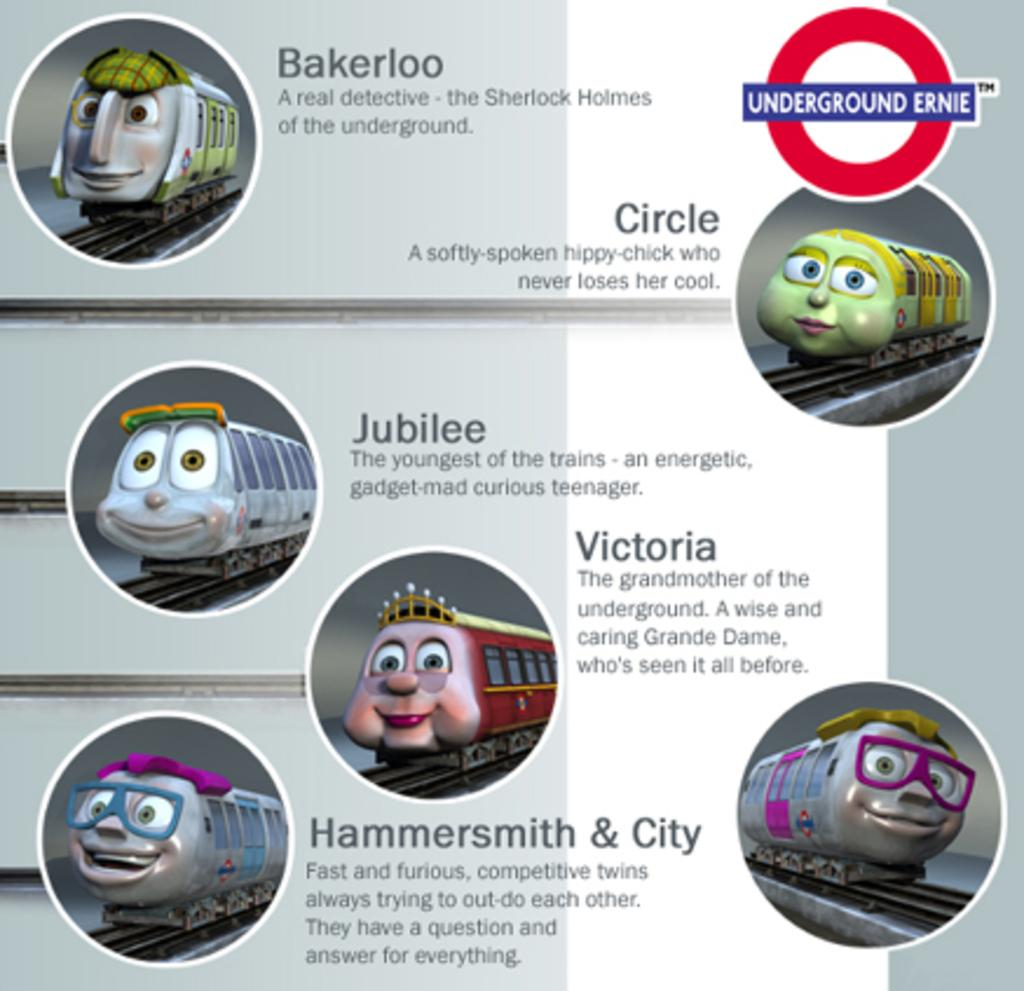What is the main subject of the poster in the image? The main subject of the poster in the image is cartoon images of trains. What other elements are present on the poster besides the train images? There are texts on the poster. What is the color of the background on the poster? The background of the poster is gray in color. What type of head can be seen on the knife depicted in the poster? There is no knife present in the poster; it contains cartoon images of trains and texts. What verse is written on the poster? There is no verse present on the poster; it contains cartoon images of trains and texts about the trains. 